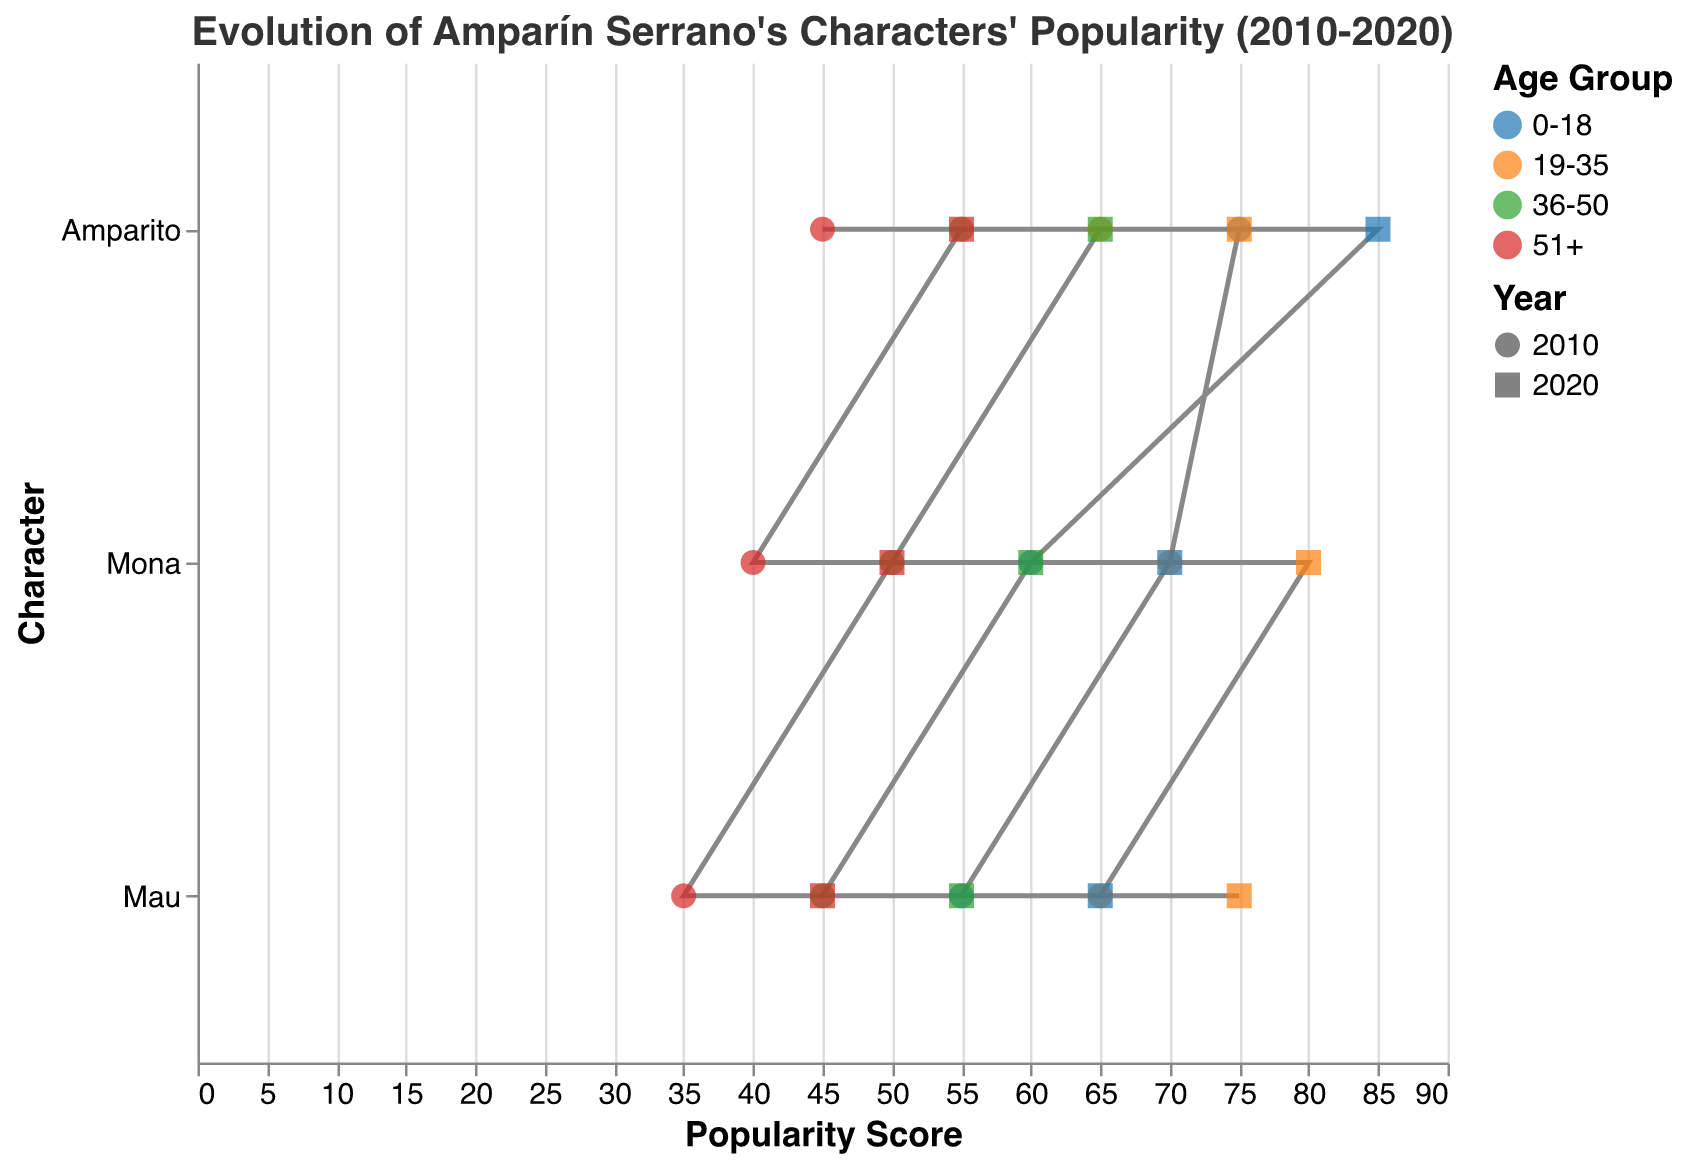Which character saw the highest increase in popularity among the 0-18 age group from 2010 to 2020? Amparito's popularity score in the 0-18 age group increased from 75 in 2010 to 85 in 2020, Mona's from 60 to 70, and Mau's from 55 to 65. The highest increase is 85 - 75 = 10, for Amparito.
Answer: Amparito Which age group had the highest popularity score increase for Mona between 2010 and 2020? The popularity score increased for Mona in 0-18 age group by 10 (70-60), in 19-35 age group by 10 (80-70), in 36-50 age group by 10 (60-50), and in 51+ age group by 10 (50-40). They all increased by the same amount.
Answer: All age groups Which character had the lowest popularity score among the 36-50 age group in 2010? Among the 36-50 age group in 2010: Amparito had a score of 55, Mona had a score of 50, and Mau had a score of 45. The lowest score is for Mau.
Answer: Mau How much did the popularity score of Amparito increase in the 19-35 age group from 2010 to 2020? The popularity score of Amparito in the 19-35 age group was 65 in 2010 and increased to 75 in 2020. The increase is 75 - 65 = 10.
Answer: 10 Between 2010 and 2020, how much did the popularity score of Amparito change in the 51+ age group, and did it increase or decrease? The popularity score of Amparito in the 51+ age group was 45 in 2010 and 55 in 2020. The change is 55 - 45 = 10, indicating an increase.
Answer: Increased by 10 Which character had the highest popularity score in the 19-35 age group in 2020? In 2020, Amparito had a popularity score of 75, Mona had a score of 80, and Mau had a score of 75 in the 19-35 age group. The highest score is 80, for Mona.
Answer: Mona What is the overall trend in popularity scores for Amparito across all age groups from 2010 to 2020? The data shows that Amparito's popularity score increased across all age groups from 2010 to 2020: 0-18 (75 to 85), 19-35 (65 to 75), 36-50 (55 to 65), and 51+ (45 to 55). The overall trend is an increase.
Answer: Increase Which age group shows the least change in popularity score for Mona from 2010 to 2020? Mona's popularity scores: 0-18 (60 to 70), 19-35 (70 to 80), 36-50 (50 to 60), 51+ (40 to 50). The least change is 10 for all age groups, meaning all changed equally.
Answer: All age groups 